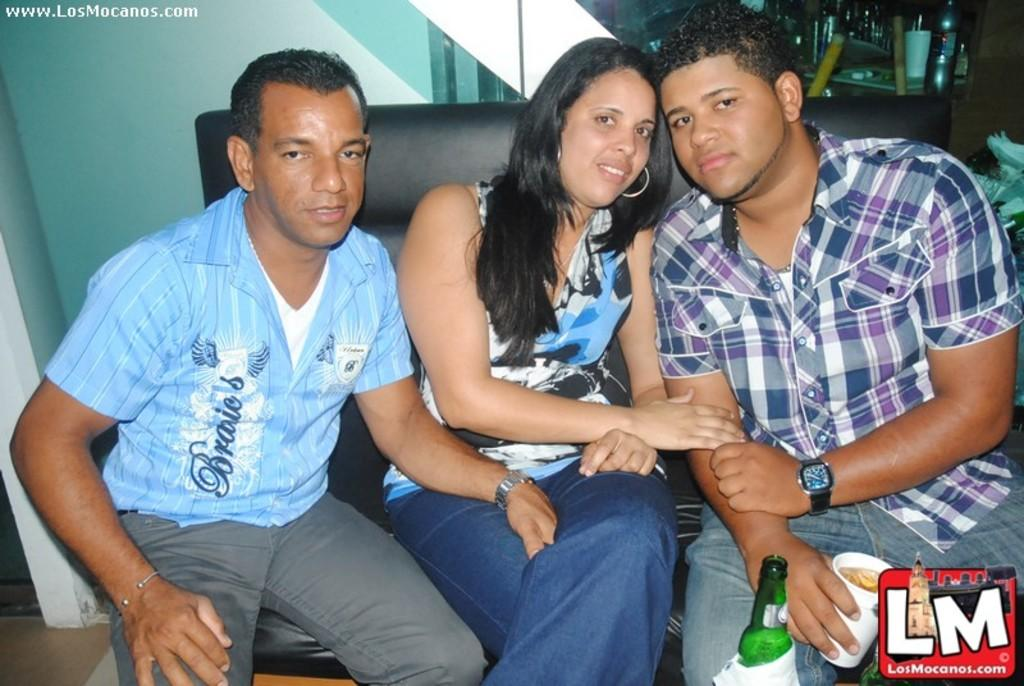<image>
Present a compact description of the photo's key features. A photo of a woman seated between two men with a LosMocanos watermark. 